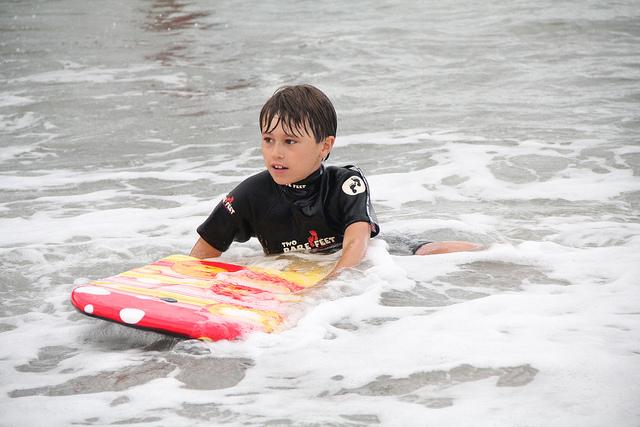Is he having fun?
Short answer required. Yes. What is the boy sitting on?
Keep it brief. Surfboard. What color is the boy's shirt?
Give a very brief answer. Black. Is the boy in water?
Be succinct. Yes. What color is the board?
Quick response, please. Red and yellow. 